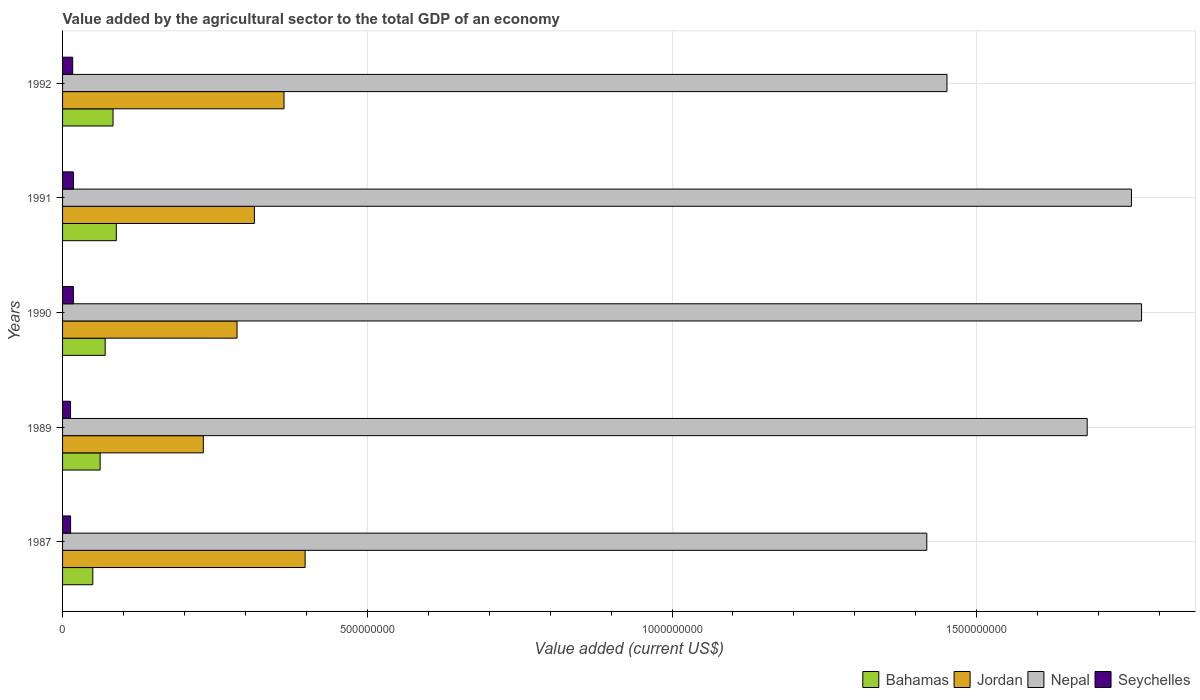How many groups of bars are there?
Give a very brief answer. 5. Are the number of bars per tick equal to the number of legend labels?
Give a very brief answer. Yes. How many bars are there on the 4th tick from the bottom?
Your answer should be compact. 4. What is the label of the 1st group of bars from the top?
Your answer should be very brief. 1992. What is the value added by the agricultural sector to the total GDP in Nepal in 1990?
Offer a very short reply. 1.77e+09. Across all years, what is the maximum value added by the agricultural sector to the total GDP in Bahamas?
Ensure brevity in your answer.  8.82e+07. Across all years, what is the minimum value added by the agricultural sector to the total GDP in Bahamas?
Your response must be concise. 4.96e+07. In which year was the value added by the agricultural sector to the total GDP in Nepal minimum?
Make the answer very short. 1987. What is the total value added by the agricultural sector to the total GDP in Bahamas in the graph?
Your answer should be compact. 3.52e+08. What is the difference between the value added by the agricultural sector to the total GDP in Seychelles in 1987 and that in 1992?
Ensure brevity in your answer.  -3.40e+06. What is the difference between the value added by the agricultural sector to the total GDP in Nepal in 1987 and the value added by the agricultural sector to the total GDP in Seychelles in 1991?
Make the answer very short. 1.40e+09. What is the average value added by the agricultural sector to the total GDP in Bahamas per year?
Give a very brief answer. 7.04e+07. In the year 1987, what is the difference between the value added by the agricultural sector to the total GDP in Jordan and value added by the agricultural sector to the total GDP in Seychelles?
Provide a succinct answer. 3.85e+08. In how many years, is the value added by the agricultural sector to the total GDP in Jordan greater than 1500000000 US$?
Keep it short and to the point. 0. What is the ratio of the value added by the agricultural sector to the total GDP in Seychelles in 1991 to that in 1992?
Make the answer very short. 1.08. Is the value added by the agricultural sector to the total GDP in Nepal in 1990 less than that in 1992?
Your answer should be very brief. No. What is the difference between the highest and the second highest value added by the agricultural sector to the total GDP in Bahamas?
Give a very brief answer. 5.37e+06. What is the difference between the highest and the lowest value added by the agricultural sector to the total GDP in Seychelles?
Ensure brevity in your answer.  4.80e+06. In how many years, is the value added by the agricultural sector to the total GDP in Bahamas greater than the average value added by the agricultural sector to the total GDP in Bahamas taken over all years?
Ensure brevity in your answer.  2. Is it the case that in every year, the sum of the value added by the agricultural sector to the total GDP in Bahamas and value added by the agricultural sector to the total GDP in Nepal is greater than the sum of value added by the agricultural sector to the total GDP in Jordan and value added by the agricultural sector to the total GDP in Seychelles?
Provide a short and direct response. Yes. What does the 1st bar from the top in 1987 represents?
Make the answer very short. Seychelles. What does the 1st bar from the bottom in 1990 represents?
Ensure brevity in your answer.  Bahamas. Is it the case that in every year, the sum of the value added by the agricultural sector to the total GDP in Bahamas and value added by the agricultural sector to the total GDP in Nepal is greater than the value added by the agricultural sector to the total GDP in Seychelles?
Your answer should be compact. Yes. How many bars are there?
Ensure brevity in your answer.  20. How many years are there in the graph?
Keep it short and to the point. 5. Does the graph contain grids?
Offer a terse response. Yes. How are the legend labels stacked?
Keep it short and to the point. Horizontal. What is the title of the graph?
Provide a succinct answer. Value added by the agricultural sector to the total GDP of an economy. What is the label or title of the X-axis?
Give a very brief answer. Value added (current US$). What is the Value added (current US$) in Bahamas in 1987?
Provide a short and direct response. 4.96e+07. What is the Value added (current US$) in Jordan in 1987?
Offer a very short reply. 3.98e+08. What is the Value added (current US$) in Nepal in 1987?
Provide a short and direct response. 1.42e+09. What is the Value added (current US$) in Seychelles in 1987?
Offer a very short reply. 1.32e+07. What is the Value added (current US$) in Bahamas in 1989?
Offer a terse response. 6.16e+07. What is the Value added (current US$) of Jordan in 1989?
Provide a succinct answer. 2.31e+08. What is the Value added (current US$) of Nepal in 1989?
Provide a succinct answer. 1.68e+09. What is the Value added (current US$) in Seychelles in 1989?
Offer a very short reply. 1.31e+07. What is the Value added (current US$) of Bahamas in 1990?
Give a very brief answer. 6.99e+07. What is the Value added (current US$) in Jordan in 1990?
Keep it short and to the point. 2.86e+08. What is the Value added (current US$) of Nepal in 1990?
Offer a very short reply. 1.77e+09. What is the Value added (current US$) of Seychelles in 1990?
Offer a terse response. 1.77e+07. What is the Value added (current US$) of Bahamas in 1991?
Offer a terse response. 8.82e+07. What is the Value added (current US$) of Jordan in 1991?
Make the answer very short. 3.15e+08. What is the Value added (current US$) in Nepal in 1991?
Your answer should be compact. 1.75e+09. What is the Value added (current US$) of Seychelles in 1991?
Offer a very short reply. 1.79e+07. What is the Value added (current US$) in Bahamas in 1992?
Offer a terse response. 8.28e+07. What is the Value added (current US$) of Jordan in 1992?
Offer a very short reply. 3.63e+08. What is the Value added (current US$) of Nepal in 1992?
Offer a terse response. 1.45e+09. What is the Value added (current US$) in Seychelles in 1992?
Give a very brief answer. 1.66e+07. Across all years, what is the maximum Value added (current US$) of Bahamas?
Your answer should be compact. 8.82e+07. Across all years, what is the maximum Value added (current US$) of Jordan?
Your response must be concise. 3.98e+08. Across all years, what is the maximum Value added (current US$) in Nepal?
Provide a short and direct response. 1.77e+09. Across all years, what is the maximum Value added (current US$) in Seychelles?
Make the answer very short. 1.79e+07. Across all years, what is the minimum Value added (current US$) in Bahamas?
Provide a succinct answer. 4.96e+07. Across all years, what is the minimum Value added (current US$) in Jordan?
Offer a terse response. 2.31e+08. Across all years, what is the minimum Value added (current US$) of Nepal?
Provide a succinct answer. 1.42e+09. Across all years, what is the minimum Value added (current US$) of Seychelles?
Your response must be concise. 1.31e+07. What is the total Value added (current US$) of Bahamas in the graph?
Your answer should be compact. 3.52e+08. What is the total Value added (current US$) in Jordan in the graph?
Give a very brief answer. 1.59e+09. What is the total Value added (current US$) in Nepal in the graph?
Ensure brevity in your answer.  8.07e+09. What is the total Value added (current US$) in Seychelles in the graph?
Your answer should be very brief. 7.85e+07. What is the difference between the Value added (current US$) of Bahamas in 1987 and that in 1989?
Ensure brevity in your answer.  -1.20e+07. What is the difference between the Value added (current US$) in Jordan in 1987 and that in 1989?
Keep it short and to the point. 1.67e+08. What is the difference between the Value added (current US$) of Nepal in 1987 and that in 1989?
Your answer should be very brief. -2.63e+08. What is the difference between the Value added (current US$) of Seychelles in 1987 and that in 1989?
Keep it short and to the point. 1.07e+05. What is the difference between the Value added (current US$) in Bahamas in 1987 and that in 1990?
Your response must be concise. -2.03e+07. What is the difference between the Value added (current US$) in Jordan in 1987 and that in 1990?
Your answer should be very brief. 1.12e+08. What is the difference between the Value added (current US$) of Nepal in 1987 and that in 1990?
Your answer should be compact. -3.52e+08. What is the difference between the Value added (current US$) of Seychelles in 1987 and that in 1990?
Your response must be concise. -4.53e+06. What is the difference between the Value added (current US$) in Bahamas in 1987 and that in 1991?
Your response must be concise. -3.86e+07. What is the difference between the Value added (current US$) in Jordan in 1987 and that in 1991?
Your response must be concise. 8.32e+07. What is the difference between the Value added (current US$) of Nepal in 1987 and that in 1991?
Make the answer very short. -3.36e+08. What is the difference between the Value added (current US$) of Seychelles in 1987 and that in 1991?
Make the answer very short. -4.69e+06. What is the difference between the Value added (current US$) of Bahamas in 1987 and that in 1992?
Ensure brevity in your answer.  -3.32e+07. What is the difference between the Value added (current US$) of Jordan in 1987 and that in 1992?
Provide a succinct answer. 3.46e+07. What is the difference between the Value added (current US$) in Nepal in 1987 and that in 1992?
Ensure brevity in your answer.  -3.31e+07. What is the difference between the Value added (current US$) in Seychelles in 1987 and that in 1992?
Make the answer very short. -3.40e+06. What is the difference between the Value added (current US$) of Bahamas in 1989 and that in 1990?
Provide a short and direct response. -8.30e+06. What is the difference between the Value added (current US$) in Jordan in 1989 and that in 1990?
Your answer should be compact. -5.53e+07. What is the difference between the Value added (current US$) in Nepal in 1989 and that in 1990?
Offer a terse response. -8.92e+07. What is the difference between the Value added (current US$) in Seychelles in 1989 and that in 1990?
Your answer should be very brief. -4.64e+06. What is the difference between the Value added (current US$) in Bahamas in 1989 and that in 1991?
Make the answer very short. -2.65e+07. What is the difference between the Value added (current US$) of Jordan in 1989 and that in 1991?
Your response must be concise. -8.38e+07. What is the difference between the Value added (current US$) of Nepal in 1989 and that in 1991?
Your response must be concise. -7.27e+07. What is the difference between the Value added (current US$) in Seychelles in 1989 and that in 1991?
Provide a succinct answer. -4.80e+06. What is the difference between the Value added (current US$) of Bahamas in 1989 and that in 1992?
Offer a very short reply. -2.12e+07. What is the difference between the Value added (current US$) in Jordan in 1989 and that in 1992?
Your answer should be very brief. -1.32e+08. What is the difference between the Value added (current US$) in Nepal in 1989 and that in 1992?
Offer a very short reply. 2.30e+08. What is the difference between the Value added (current US$) in Seychelles in 1989 and that in 1992?
Offer a terse response. -3.51e+06. What is the difference between the Value added (current US$) of Bahamas in 1990 and that in 1991?
Your answer should be very brief. -1.82e+07. What is the difference between the Value added (current US$) in Jordan in 1990 and that in 1991?
Your answer should be compact. -2.85e+07. What is the difference between the Value added (current US$) of Nepal in 1990 and that in 1991?
Ensure brevity in your answer.  1.65e+07. What is the difference between the Value added (current US$) of Seychelles in 1990 and that in 1991?
Give a very brief answer. -1.60e+05. What is the difference between the Value added (current US$) of Bahamas in 1990 and that in 1992?
Your answer should be very brief. -1.29e+07. What is the difference between the Value added (current US$) of Jordan in 1990 and that in 1992?
Ensure brevity in your answer.  -7.71e+07. What is the difference between the Value added (current US$) of Nepal in 1990 and that in 1992?
Your response must be concise. 3.19e+08. What is the difference between the Value added (current US$) in Seychelles in 1990 and that in 1992?
Provide a short and direct response. 1.13e+06. What is the difference between the Value added (current US$) of Bahamas in 1991 and that in 1992?
Your response must be concise. 5.37e+06. What is the difference between the Value added (current US$) of Jordan in 1991 and that in 1992?
Provide a succinct answer. -4.86e+07. What is the difference between the Value added (current US$) of Nepal in 1991 and that in 1992?
Make the answer very short. 3.03e+08. What is the difference between the Value added (current US$) of Seychelles in 1991 and that in 1992?
Give a very brief answer. 1.29e+06. What is the difference between the Value added (current US$) of Bahamas in 1987 and the Value added (current US$) of Jordan in 1989?
Your answer should be compact. -1.81e+08. What is the difference between the Value added (current US$) of Bahamas in 1987 and the Value added (current US$) of Nepal in 1989?
Offer a terse response. -1.63e+09. What is the difference between the Value added (current US$) in Bahamas in 1987 and the Value added (current US$) in Seychelles in 1989?
Make the answer very short. 3.65e+07. What is the difference between the Value added (current US$) in Jordan in 1987 and the Value added (current US$) in Nepal in 1989?
Your answer should be compact. -1.28e+09. What is the difference between the Value added (current US$) of Jordan in 1987 and the Value added (current US$) of Seychelles in 1989?
Your answer should be very brief. 3.85e+08. What is the difference between the Value added (current US$) of Nepal in 1987 and the Value added (current US$) of Seychelles in 1989?
Offer a very short reply. 1.40e+09. What is the difference between the Value added (current US$) in Bahamas in 1987 and the Value added (current US$) in Jordan in 1990?
Ensure brevity in your answer.  -2.37e+08. What is the difference between the Value added (current US$) in Bahamas in 1987 and the Value added (current US$) in Nepal in 1990?
Keep it short and to the point. -1.72e+09. What is the difference between the Value added (current US$) in Bahamas in 1987 and the Value added (current US$) in Seychelles in 1990?
Ensure brevity in your answer.  3.19e+07. What is the difference between the Value added (current US$) of Jordan in 1987 and the Value added (current US$) of Nepal in 1990?
Your response must be concise. -1.37e+09. What is the difference between the Value added (current US$) of Jordan in 1987 and the Value added (current US$) of Seychelles in 1990?
Your response must be concise. 3.80e+08. What is the difference between the Value added (current US$) in Nepal in 1987 and the Value added (current US$) in Seychelles in 1990?
Provide a short and direct response. 1.40e+09. What is the difference between the Value added (current US$) of Bahamas in 1987 and the Value added (current US$) of Jordan in 1991?
Your response must be concise. -2.65e+08. What is the difference between the Value added (current US$) of Bahamas in 1987 and the Value added (current US$) of Nepal in 1991?
Make the answer very short. -1.70e+09. What is the difference between the Value added (current US$) of Bahamas in 1987 and the Value added (current US$) of Seychelles in 1991?
Keep it short and to the point. 3.17e+07. What is the difference between the Value added (current US$) of Jordan in 1987 and the Value added (current US$) of Nepal in 1991?
Provide a short and direct response. -1.36e+09. What is the difference between the Value added (current US$) of Jordan in 1987 and the Value added (current US$) of Seychelles in 1991?
Offer a terse response. 3.80e+08. What is the difference between the Value added (current US$) in Nepal in 1987 and the Value added (current US$) in Seychelles in 1991?
Offer a very short reply. 1.40e+09. What is the difference between the Value added (current US$) in Bahamas in 1987 and the Value added (current US$) in Jordan in 1992?
Make the answer very short. -3.14e+08. What is the difference between the Value added (current US$) in Bahamas in 1987 and the Value added (current US$) in Nepal in 1992?
Keep it short and to the point. -1.40e+09. What is the difference between the Value added (current US$) of Bahamas in 1987 and the Value added (current US$) of Seychelles in 1992?
Make the answer very short. 3.30e+07. What is the difference between the Value added (current US$) of Jordan in 1987 and the Value added (current US$) of Nepal in 1992?
Give a very brief answer. -1.05e+09. What is the difference between the Value added (current US$) in Jordan in 1987 and the Value added (current US$) in Seychelles in 1992?
Provide a short and direct response. 3.81e+08. What is the difference between the Value added (current US$) in Nepal in 1987 and the Value added (current US$) in Seychelles in 1992?
Provide a succinct answer. 1.40e+09. What is the difference between the Value added (current US$) in Bahamas in 1989 and the Value added (current US$) in Jordan in 1990?
Offer a terse response. -2.25e+08. What is the difference between the Value added (current US$) in Bahamas in 1989 and the Value added (current US$) in Nepal in 1990?
Keep it short and to the point. -1.71e+09. What is the difference between the Value added (current US$) in Bahamas in 1989 and the Value added (current US$) in Seychelles in 1990?
Your answer should be compact. 4.39e+07. What is the difference between the Value added (current US$) of Jordan in 1989 and the Value added (current US$) of Nepal in 1990?
Keep it short and to the point. -1.54e+09. What is the difference between the Value added (current US$) of Jordan in 1989 and the Value added (current US$) of Seychelles in 1990?
Provide a succinct answer. 2.13e+08. What is the difference between the Value added (current US$) of Nepal in 1989 and the Value added (current US$) of Seychelles in 1990?
Your response must be concise. 1.66e+09. What is the difference between the Value added (current US$) in Bahamas in 1989 and the Value added (current US$) in Jordan in 1991?
Make the answer very short. -2.53e+08. What is the difference between the Value added (current US$) in Bahamas in 1989 and the Value added (current US$) in Nepal in 1991?
Your answer should be very brief. -1.69e+09. What is the difference between the Value added (current US$) of Bahamas in 1989 and the Value added (current US$) of Seychelles in 1991?
Offer a terse response. 4.37e+07. What is the difference between the Value added (current US$) of Jordan in 1989 and the Value added (current US$) of Nepal in 1991?
Offer a very short reply. -1.52e+09. What is the difference between the Value added (current US$) of Jordan in 1989 and the Value added (current US$) of Seychelles in 1991?
Keep it short and to the point. 2.13e+08. What is the difference between the Value added (current US$) in Nepal in 1989 and the Value added (current US$) in Seychelles in 1991?
Ensure brevity in your answer.  1.66e+09. What is the difference between the Value added (current US$) of Bahamas in 1989 and the Value added (current US$) of Jordan in 1992?
Your response must be concise. -3.02e+08. What is the difference between the Value added (current US$) in Bahamas in 1989 and the Value added (current US$) in Nepal in 1992?
Ensure brevity in your answer.  -1.39e+09. What is the difference between the Value added (current US$) in Bahamas in 1989 and the Value added (current US$) in Seychelles in 1992?
Offer a very short reply. 4.50e+07. What is the difference between the Value added (current US$) in Jordan in 1989 and the Value added (current US$) in Nepal in 1992?
Offer a terse response. -1.22e+09. What is the difference between the Value added (current US$) in Jordan in 1989 and the Value added (current US$) in Seychelles in 1992?
Ensure brevity in your answer.  2.14e+08. What is the difference between the Value added (current US$) in Nepal in 1989 and the Value added (current US$) in Seychelles in 1992?
Your answer should be very brief. 1.66e+09. What is the difference between the Value added (current US$) of Bahamas in 1990 and the Value added (current US$) of Jordan in 1991?
Ensure brevity in your answer.  -2.45e+08. What is the difference between the Value added (current US$) of Bahamas in 1990 and the Value added (current US$) of Nepal in 1991?
Provide a short and direct response. -1.68e+09. What is the difference between the Value added (current US$) in Bahamas in 1990 and the Value added (current US$) in Seychelles in 1991?
Provide a succinct answer. 5.20e+07. What is the difference between the Value added (current US$) in Jordan in 1990 and the Value added (current US$) in Nepal in 1991?
Make the answer very short. -1.47e+09. What is the difference between the Value added (current US$) in Jordan in 1990 and the Value added (current US$) in Seychelles in 1991?
Ensure brevity in your answer.  2.68e+08. What is the difference between the Value added (current US$) of Nepal in 1990 and the Value added (current US$) of Seychelles in 1991?
Provide a succinct answer. 1.75e+09. What is the difference between the Value added (current US$) in Bahamas in 1990 and the Value added (current US$) in Jordan in 1992?
Your answer should be very brief. -2.93e+08. What is the difference between the Value added (current US$) in Bahamas in 1990 and the Value added (current US$) in Nepal in 1992?
Offer a very short reply. -1.38e+09. What is the difference between the Value added (current US$) of Bahamas in 1990 and the Value added (current US$) of Seychelles in 1992?
Provide a short and direct response. 5.33e+07. What is the difference between the Value added (current US$) in Jordan in 1990 and the Value added (current US$) in Nepal in 1992?
Keep it short and to the point. -1.16e+09. What is the difference between the Value added (current US$) of Jordan in 1990 and the Value added (current US$) of Seychelles in 1992?
Provide a succinct answer. 2.70e+08. What is the difference between the Value added (current US$) of Nepal in 1990 and the Value added (current US$) of Seychelles in 1992?
Keep it short and to the point. 1.75e+09. What is the difference between the Value added (current US$) in Bahamas in 1991 and the Value added (current US$) in Jordan in 1992?
Give a very brief answer. -2.75e+08. What is the difference between the Value added (current US$) in Bahamas in 1991 and the Value added (current US$) in Nepal in 1992?
Offer a terse response. -1.36e+09. What is the difference between the Value added (current US$) in Bahamas in 1991 and the Value added (current US$) in Seychelles in 1992?
Provide a short and direct response. 7.16e+07. What is the difference between the Value added (current US$) in Jordan in 1991 and the Value added (current US$) in Nepal in 1992?
Provide a short and direct response. -1.14e+09. What is the difference between the Value added (current US$) of Jordan in 1991 and the Value added (current US$) of Seychelles in 1992?
Keep it short and to the point. 2.98e+08. What is the difference between the Value added (current US$) in Nepal in 1991 and the Value added (current US$) in Seychelles in 1992?
Provide a succinct answer. 1.74e+09. What is the average Value added (current US$) of Bahamas per year?
Your answer should be compact. 7.04e+07. What is the average Value added (current US$) of Jordan per year?
Offer a terse response. 3.19e+08. What is the average Value added (current US$) of Nepal per year?
Provide a short and direct response. 1.61e+09. What is the average Value added (current US$) of Seychelles per year?
Your answer should be very brief. 1.57e+07. In the year 1987, what is the difference between the Value added (current US$) of Bahamas and Value added (current US$) of Jordan?
Give a very brief answer. -3.48e+08. In the year 1987, what is the difference between the Value added (current US$) in Bahamas and Value added (current US$) in Nepal?
Provide a succinct answer. -1.37e+09. In the year 1987, what is the difference between the Value added (current US$) in Bahamas and Value added (current US$) in Seychelles?
Give a very brief answer. 3.64e+07. In the year 1987, what is the difference between the Value added (current US$) of Jordan and Value added (current US$) of Nepal?
Keep it short and to the point. -1.02e+09. In the year 1987, what is the difference between the Value added (current US$) in Jordan and Value added (current US$) in Seychelles?
Provide a succinct answer. 3.85e+08. In the year 1987, what is the difference between the Value added (current US$) in Nepal and Value added (current US$) in Seychelles?
Your answer should be compact. 1.40e+09. In the year 1989, what is the difference between the Value added (current US$) in Bahamas and Value added (current US$) in Jordan?
Offer a very short reply. -1.69e+08. In the year 1989, what is the difference between the Value added (current US$) in Bahamas and Value added (current US$) in Nepal?
Your answer should be very brief. -1.62e+09. In the year 1989, what is the difference between the Value added (current US$) of Bahamas and Value added (current US$) of Seychelles?
Provide a short and direct response. 4.85e+07. In the year 1989, what is the difference between the Value added (current US$) in Jordan and Value added (current US$) in Nepal?
Make the answer very short. -1.45e+09. In the year 1989, what is the difference between the Value added (current US$) of Jordan and Value added (current US$) of Seychelles?
Your answer should be compact. 2.18e+08. In the year 1989, what is the difference between the Value added (current US$) in Nepal and Value added (current US$) in Seychelles?
Give a very brief answer. 1.67e+09. In the year 1990, what is the difference between the Value added (current US$) of Bahamas and Value added (current US$) of Jordan?
Provide a short and direct response. -2.16e+08. In the year 1990, what is the difference between the Value added (current US$) of Bahamas and Value added (current US$) of Nepal?
Your answer should be compact. -1.70e+09. In the year 1990, what is the difference between the Value added (current US$) of Bahamas and Value added (current US$) of Seychelles?
Your answer should be compact. 5.22e+07. In the year 1990, what is the difference between the Value added (current US$) of Jordan and Value added (current US$) of Nepal?
Give a very brief answer. -1.48e+09. In the year 1990, what is the difference between the Value added (current US$) in Jordan and Value added (current US$) in Seychelles?
Give a very brief answer. 2.69e+08. In the year 1990, what is the difference between the Value added (current US$) in Nepal and Value added (current US$) in Seychelles?
Give a very brief answer. 1.75e+09. In the year 1991, what is the difference between the Value added (current US$) in Bahamas and Value added (current US$) in Jordan?
Give a very brief answer. -2.27e+08. In the year 1991, what is the difference between the Value added (current US$) of Bahamas and Value added (current US$) of Nepal?
Your answer should be compact. -1.67e+09. In the year 1991, what is the difference between the Value added (current US$) of Bahamas and Value added (current US$) of Seychelles?
Your response must be concise. 7.03e+07. In the year 1991, what is the difference between the Value added (current US$) of Jordan and Value added (current US$) of Nepal?
Ensure brevity in your answer.  -1.44e+09. In the year 1991, what is the difference between the Value added (current US$) in Jordan and Value added (current US$) in Seychelles?
Ensure brevity in your answer.  2.97e+08. In the year 1991, what is the difference between the Value added (current US$) of Nepal and Value added (current US$) of Seychelles?
Offer a very short reply. 1.74e+09. In the year 1992, what is the difference between the Value added (current US$) in Bahamas and Value added (current US$) in Jordan?
Offer a terse response. -2.81e+08. In the year 1992, what is the difference between the Value added (current US$) of Bahamas and Value added (current US$) of Nepal?
Provide a short and direct response. -1.37e+09. In the year 1992, what is the difference between the Value added (current US$) in Bahamas and Value added (current US$) in Seychelles?
Your response must be concise. 6.62e+07. In the year 1992, what is the difference between the Value added (current US$) of Jordan and Value added (current US$) of Nepal?
Offer a very short reply. -1.09e+09. In the year 1992, what is the difference between the Value added (current US$) in Jordan and Value added (current US$) in Seychelles?
Your answer should be very brief. 3.47e+08. In the year 1992, what is the difference between the Value added (current US$) in Nepal and Value added (current US$) in Seychelles?
Provide a short and direct response. 1.43e+09. What is the ratio of the Value added (current US$) in Bahamas in 1987 to that in 1989?
Provide a short and direct response. 0.8. What is the ratio of the Value added (current US$) in Jordan in 1987 to that in 1989?
Make the answer very short. 1.72. What is the ratio of the Value added (current US$) in Nepal in 1987 to that in 1989?
Give a very brief answer. 0.84. What is the ratio of the Value added (current US$) in Seychelles in 1987 to that in 1989?
Ensure brevity in your answer.  1.01. What is the ratio of the Value added (current US$) in Bahamas in 1987 to that in 1990?
Provide a succinct answer. 0.71. What is the ratio of the Value added (current US$) of Jordan in 1987 to that in 1990?
Ensure brevity in your answer.  1.39. What is the ratio of the Value added (current US$) of Nepal in 1987 to that in 1990?
Offer a terse response. 0.8. What is the ratio of the Value added (current US$) in Seychelles in 1987 to that in 1990?
Keep it short and to the point. 0.74. What is the ratio of the Value added (current US$) of Bahamas in 1987 to that in 1991?
Your answer should be very brief. 0.56. What is the ratio of the Value added (current US$) of Jordan in 1987 to that in 1991?
Provide a short and direct response. 1.26. What is the ratio of the Value added (current US$) of Nepal in 1987 to that in 1991?
Your response must be concise. 0.81. What is the ratio of the Value added (current US$) in Seychelles in 1987 to that in 1991?
Your answer should be very brief. 0.74. What is the ratio of the Value added (current US$) in Bahamas in 1987 to that in 1992?
Ensure brevity in your answer.  0.6. What is the ratio of the Value added (current US$) of Jordan in 1987 to that in 1992?
Offer a very short reply. 1.1. What is the ratio of the Value added (current US$) in Nepal in 1987 to that in 1992?
Offer a very short reply. 0.98. What is the ratio of the Value added (current US$) of Seychelles in 1987 to that in 1992?
Your answer should be very brief. 0.8. What is the ratio of the Value added (current US$) of Bahamas in 1989 to that in 1990?
Your answer should be compact. 0.88. What is the ratio of the Value added (current US$) in Jordan in 1989 to that in 1990?
Provide a succinct answer. 0.81. What is the ratio of the Value added (current US$) of Nepal in 1989 to that in 1990?
Ensure brevity in your answer.  0.95. What is the ratio of the Value added (current US$) of Seychelles in 1989 to that in 1990?
Keep it short and to the point. 0.74. What is the ratio of the Value added (current US$) in Bahamas in 1989 to that in 1991?
Ensure brevity in your answer.  0.7. What is the ratio of the Value added (current US$) in Jordan in 1989 to that in 1991?
Keep it short and to the point. 0.73. What is the ratio of the Value added (current US$) of Nepal in 1989 to that in 1991?
Give a very brief answer. 0.96. What is the ratio of the Value added (current US$) of Seychelles in 1989 to that in 1991?
Provide a short and direct response. 0.73. What is the ratio of the Value added (current US$) of Bahamas in 1989 to that in 1992?
Provide a short and direct response. 0.74. What is the ratio of the Value added (current US$) of Jordan in 1989 to that in 1992?
Your answer should be very brief. 0.64. What is the ratio of the Value added (current US$) in Nepal in 1989 to that in 1992?
Your answer should be compact. 1.16. What is the ratio of the Value added (current US$) in Seychelles in 1989 to that in 1992?
Make the answer very short. 0.79. What is the ratio of the Value added (current US$) of Bahamas in 1990 to that in 1991?
Offer a very short reply. 0.79. What is the ratio of the Value added (current US$) of Jordan in 1990 to that in 1991?
Your answer should be very brief. 0.91. What is the ratio of the Value added (current US$) in Nepal in 1990 to that in 1991?
Your answer should be very brief. 1.01. What is the ratio of the Value added (current US$) of Seychelles in 1990 to that in 1991?
Ensure brevity in your answer.  0.99. What is the ratio of the Value added (current US$) of Bahamas in 1990 to that in 1992?
Ensure brevity in your answer.  0.84. What is the ratio of the Value added (current US$) of Jordan in 1990 to that in 1992?
Keep it short and to the point. 0.79. What is the ratio of the Value added (current US$) of Nepal in 1990 to that in 1992?
Your answer should be very brief. 1.22. What is the ratio of the Value added (current US$) of Seychelles in 1990 to that in 1992?
Offer a terse response. 1.07. What is the ratio of the Value added (current US$) in Bahamas in 1991 to that in 1992?
Your answer should be compact. 1.06. What is the ratio of the Value added (current US$) in Jordan in 1991 to that in 1992?
Offer a terse response. 0.87. What is the ratio of the Value added (current US$) of Nepal in 1991 to that in 1992?
Your answer should be very brief. 1.21. What is the ratio of the Value added (current US$) in Seychelles in 1991 to that in 1992?
Your response must be concise. 1.08. What is the difference between the highest and the second highest Value added (current US$) of Bahamas?
Offer a terse response. 5.37e+06. What is the difference between the highest and the second highest Value added (current US$) in Jordan?
Keep it short and to the point. 3.46e+07. What is the difference between the highest and the second highest Value added (current US$) of Nepal?
Give a very brief answer. 1.65e+07. What is the difference between the highest and the second highest Value added (current US$) in Seychelles?
Your answer should be compact. 1.60e+05. What is the difference between the highest and the lowest Value added (current US$) of Bahamas?
Give a very brief answer. 3.86e+07. What is the difference between the highest and the lowest Value added (current US$) in Jordan?
Offer a very short reply. 1.67e+08. What is the difference between the highest and the lowest Value added (current US$) in Nepal?
Your answer should be very brief. 3.52e+08. What is the difference between the highest and the lowest Value added (current US$) in Seychelles?
Your answer should be very brief. 4.80e+06. 